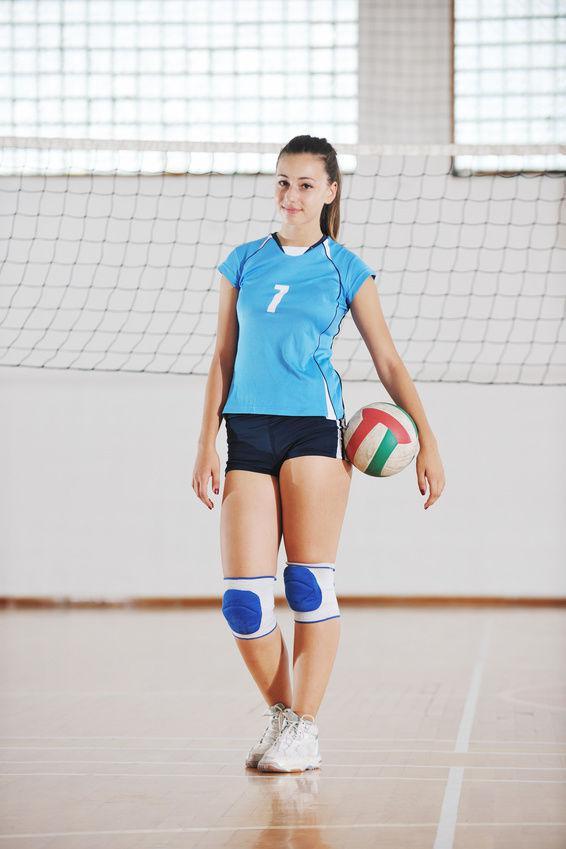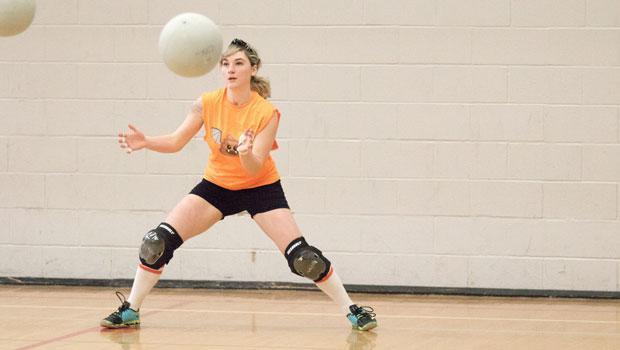The first image is the image on the left, the second image is the image on the right. Examine the images to the left and right. Is the description "The left and right image contains a total of two women playing volleyball." accurate? Answer yes or no. Yes. The first image is the image on the left, the second image is the image on the right. Evaluate the accuracy of this statement regarding the images: "One image features an upright girl reaching toward a volleyball with at least one foot off the ground, and the other image features a girl on at least one knee with a volleyball in front of one arm.". Is it true? Answer yes or no. No. 